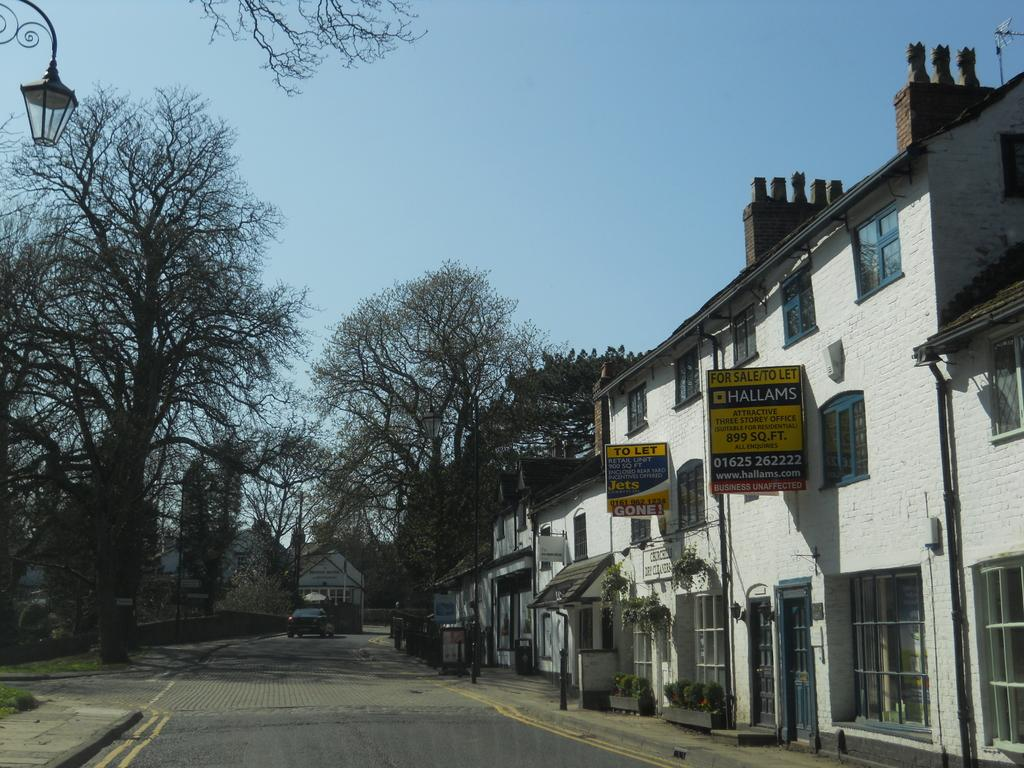What type of vegetation can be seen in the image? There are trees and plants in the image. What type of man-made structure is present in the image? There are buildings and a street lamp in the image. What is visible in the sky in the image? The sky is visible in the image. What type of lighting is present in the image? There is a street lamp in the image. What type of decorative elements can be seen in the image? There are banners in the image. What type of transportation is present in the image? There are cars in the image. What type of brick is used to construct the office building in the image? There is no office building present in the image. Can you describe the stream that runs through the image? There is no stream present in the image. 